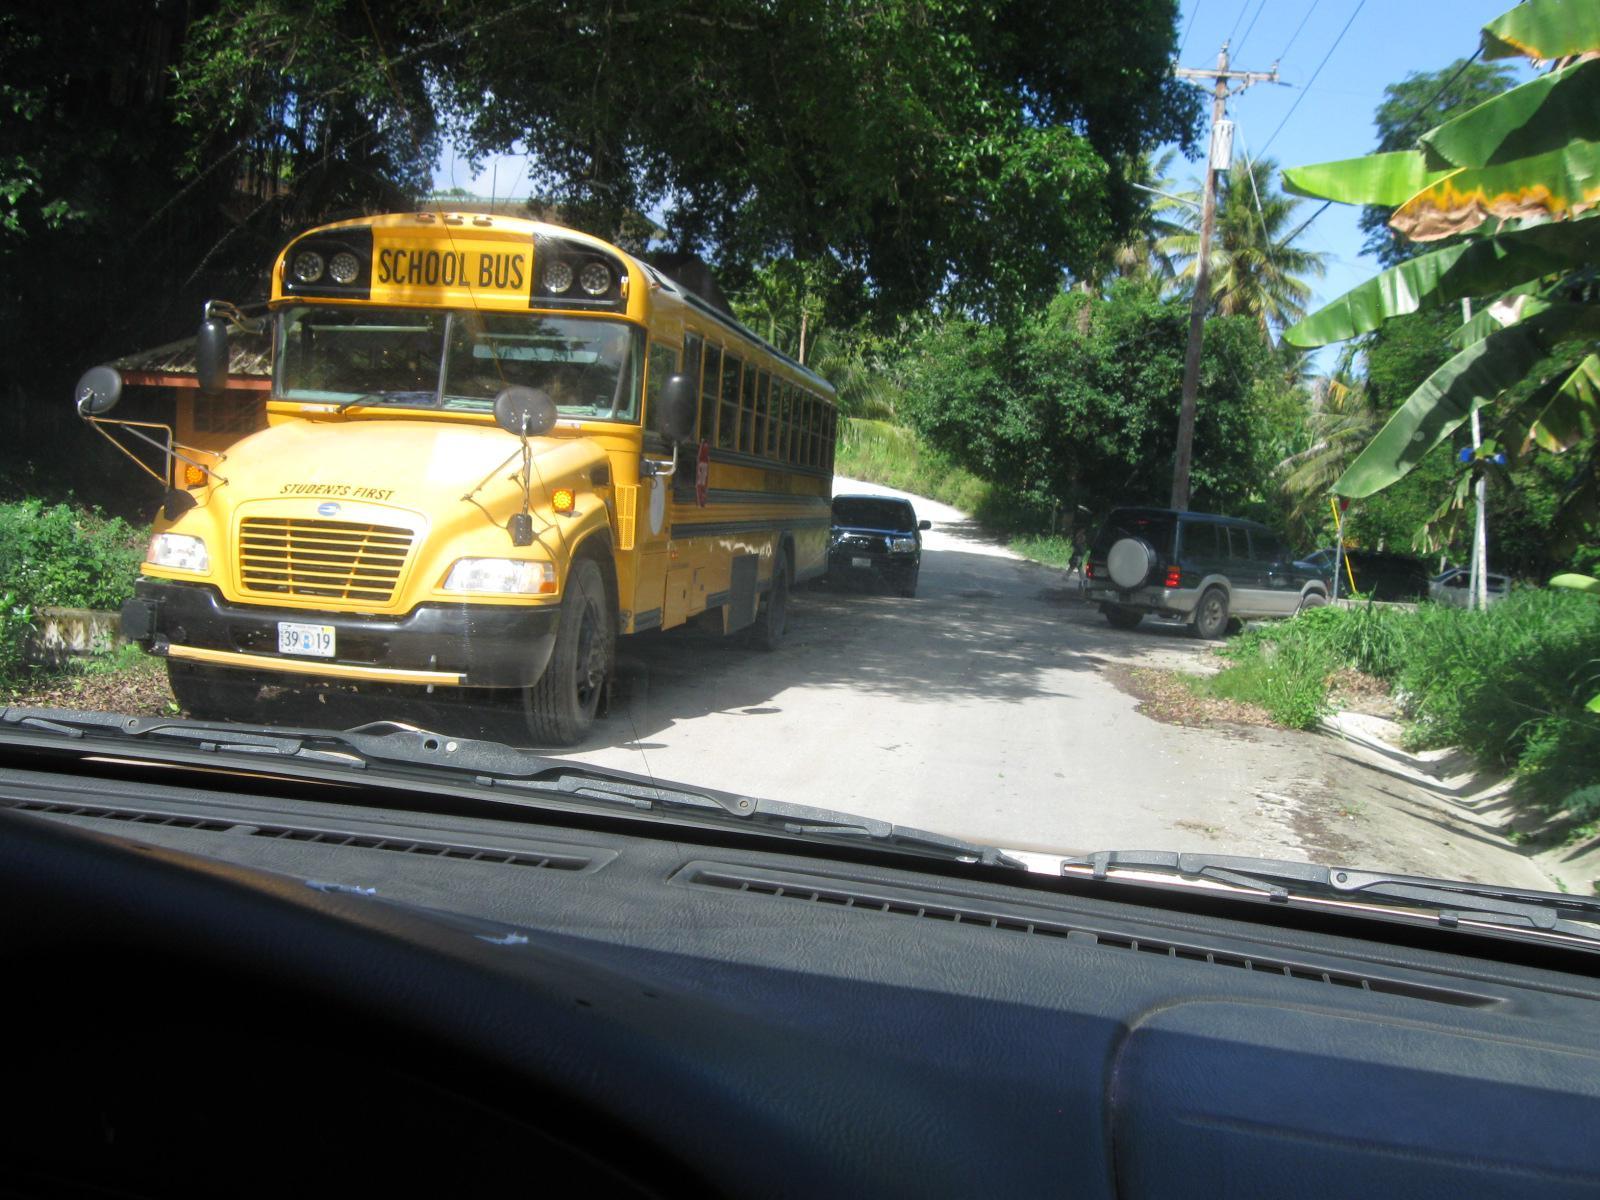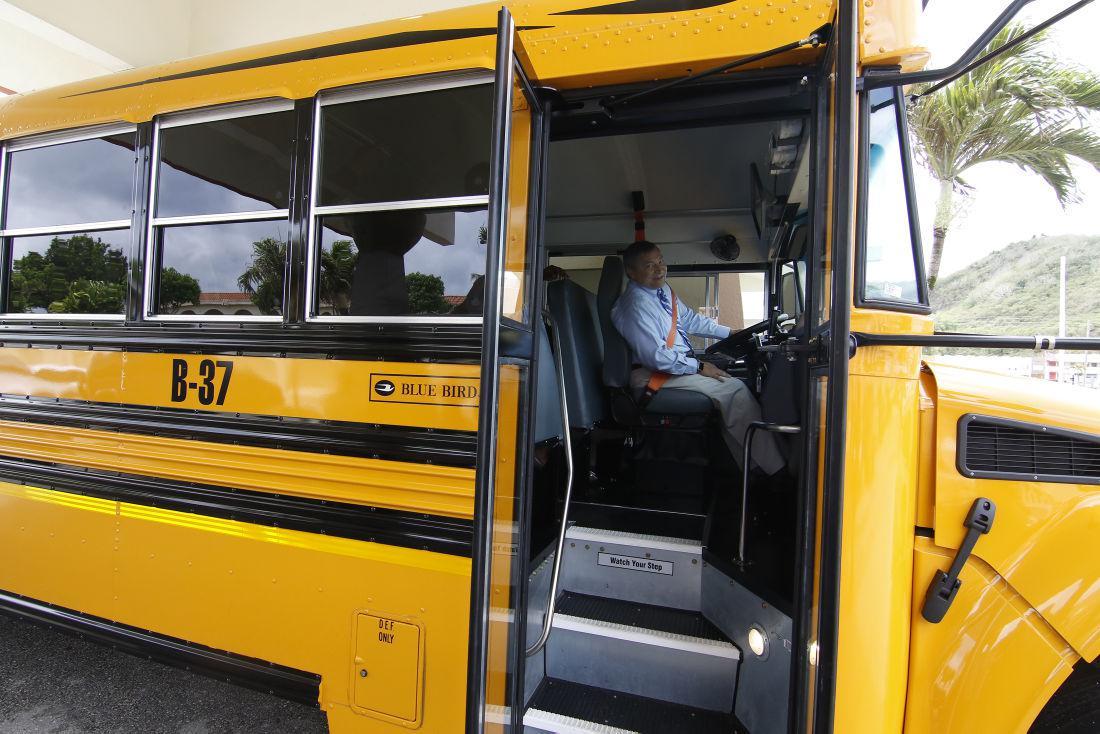The first image is the image on the left, the second image is the image on the right. Assess this claim about the two images: "The right image contains at least three school buses.". Correct or not? Answer yes or no. No. The first image is the image on the left, the second image is the image on the right. Evaluate the accuracy of this statement regarding the images: "The door of the bus in the image on the right is open.". Is it true? Answer yes or no. Yes. 